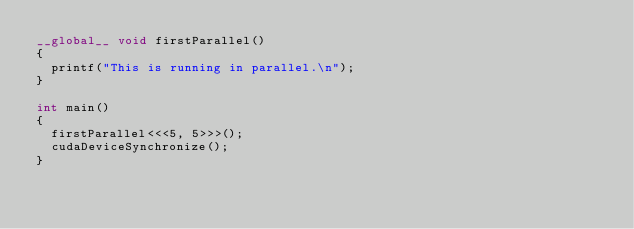<code> <loc_0><loc_0><loc_500><loc_500><_Cuda_>__global__ void firstParallel()
{
  printf("This is running in parallel.\n");
}

int main()
{
  firstParallel<<<5, 5>>>();
  cudaDeviceSynchronize();
}
</code> 